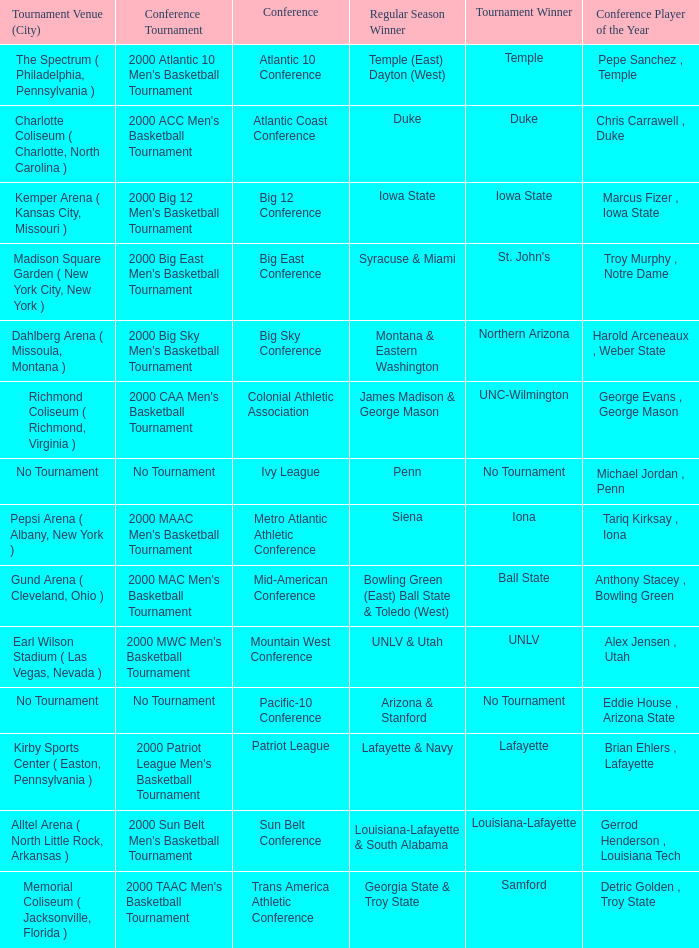Who is the regular season winner for the Ivy League conference? Penn. 